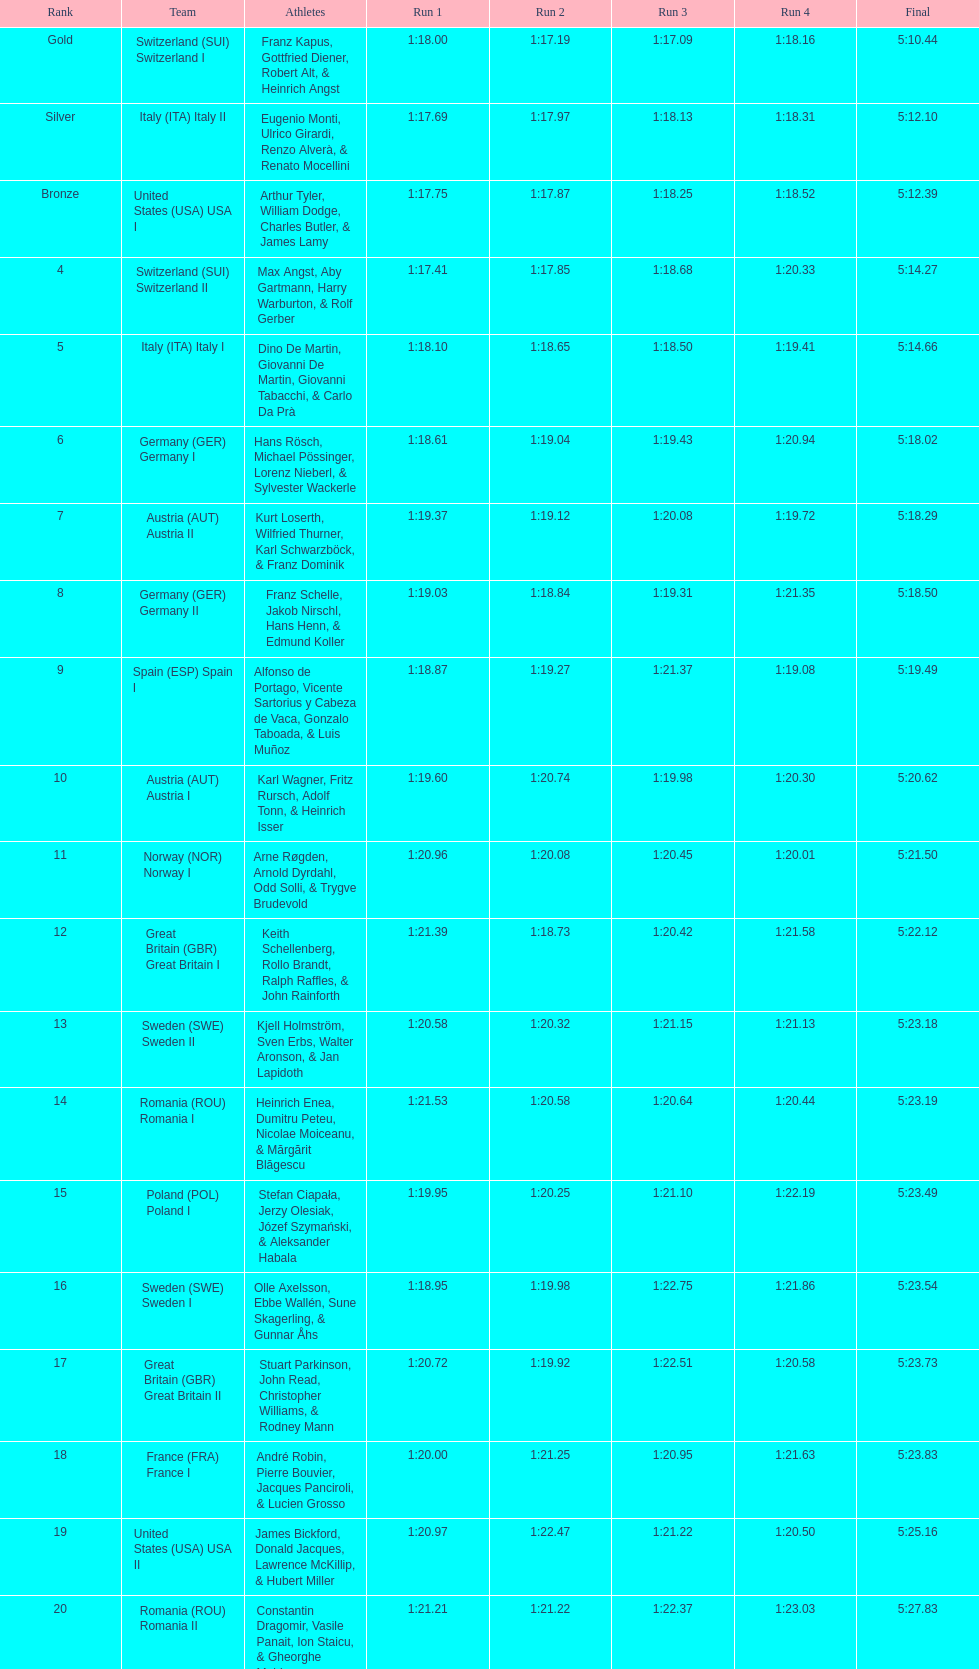Help me parse the entirety of this table. {'header': ['Rank', 'Team', 'Athletes', 'Run 1', 'Run 2', 'Run 3', 'Run 4', 'Final'], 'rows': [['Gold', 'Switzerland\xa0(SUI) Switzerland I', 'Franz Kapus, Gottfried Diener, Robert Alt, & Heinrich Angst', '1:18.00', '1:17.19', '1:17.09', '1:18.16', '5:10.44'], ['Silver', 'Italy\xa0(ITA) Italy II', 'Eugenio Monti, Ulrico Girardi, Renzo Alverà, & Renato Mocellini', '1:17.69', '1:17.97', '1:18.13', '1:18.31', '5:12.10'], ['Bronze', 'United States\xa0(USA) USA I', 'Arthur Tyler, William Dodge, Charles Butler, & James Lamy', '1:17.75', '1:17.87', '1:18.25', '1:18.52', '5:12.39'], ['4', 'Switzerland\xa0(SUI) Switzerland II', 'Max Angst, Aby Gartmann, Harry Warburton, & Rolf Gerber', '1:17.41', '1:17.85', '1:18.68', '1:20.33', '5:14.27'], ['5', 'Italy\xa0(ITA) Italy I', 'Dino De Martin, Giovanni De Martin, Giovanni Tabacchi, & Carlo Da Prà', '1:18.10', '1:18.65', '1:18.50', '1:19.41', '5:14.66'], ['6', 'Germany\xa0(GER) Germany I', 'Hans Rösch, Michael Pössinger, Lorenz Nieberl, & Sylvester Wackerle', '1:18.61', '1:19.04', '1:19.43', '1:20.94', '5:18.02'], ['7', 'Austria\xa0(AUT) Austria II', 'Kurt Loserth, Wilfried Thurner, Karl Schwarzböck, & Franz Dominik', '1:19.37', '1:19.12', '1:20.08', '1:19.72', '5:18.29'], ['8', 'Germany\xa0(GER) Germany II', 'Franz Schelle, Jakob Nirschl, Hans Henn, & Edmund Koller', '1:19.03', '1:18.84', '1:19.31', '1:21.35', '5:18.50'], ['9', 'Spain\xa0(ESP) Spain I', 'Alfonso de Portago, Vicente Sartorius y Cabeza de Vaca, Gonzalo Taboada, & Luis Muñoz', '1:18.87', '1:19.27', '1:21.37', '1:19.08', '5:19.49'], ['10', 'Austria\xa0(AUT) Austria I', 'Karl Wagner, Fritz Rursch, Adolf Tonn, & Heinrich Isser', '1:19.60', '1:20.74', '1:19.98', '1:20.30', '5:20.62'], ['11', 'Norway\xa0(NOR) Norway I', 'Arne Røgden, Arnold Dyrdahl, Odd Solli, & Trygve Brudevold', '1:20.96', '1:20.08', '1:20.45', '1:20.01', '5:21.50'], ['12', 'Great Britain\xa0(GBR) Great Britain I', 'Keith Schellenberg, Rollo Brandt, Ralph Raffles, & John Rainforth', '1:21.39', '1:18.73', '1:20.42', '1:21.58', '5:22.12'], ['13', 'Sweden\xa0(SWE) Sweden II', 'Kjell Holmström, Sven Erbs, Walter Aronson, & Jan Lapidoth', '1:20.58', '1:20.32', '1:21.15', '1:21.13', '5:23.18'], ['14', 'Romania\xa0(ROU) Romania I', 'Heinrich Enea, Dumitru Peteu, Nicolae Moiceanu, & Mărgărit Blăgescu', '1:21.53', '1:20.58', '1:20.64', '1:20.44', '5:23.19'], ['15', 'Poland\xa0(POL) Poland I', 'Stefan Ciapała, Jerzy Olesiak, Józef Szymański, & Aleksander Habala', '1:19.95', '1:20.25', '1:21.10', '1:22.19', '5:23.49'], ['16', 'Sweden\xa0(SWE) Sweden I', 'Olle Axelsson, Ebbe Wallén, Sune Skagerling, & Gunnar Åhs', '1:18.95', '1:19.98', '1:22.75', '1:21.86', '5:23.54'], ['17', 'Great Britain\xa0(GBR) Great Britain II', 'Stuart Parkinson, John Read, Christopher Williams, & Rodney Mann', '1:20.72', '1:19.92', '1:22.51', '1:20.58', '5:23.73'], ['18', 'France\xa0(FRA) France I', 'André Robin, Pierre Bouvier, Jacques Panciroli, & Lucien Grosso', '1:20.00', '1:21.25', '1:20.95', '1:21.63', '5:23.83'], ['19', 'United States\xa0(USA) USA II', 'James Bickford, Donald Jacques, Lawrence McKillip, & Hubert Miller', '1:20.97', '1:22.47', '1:21.22', '1:20.50', '5:25.16'], ['20', 'Romania\xa0(ROU) Romania II', 'Constantin Dragomir, Vasile Panait, Ion Staicu, & Gheorghe Moldoveanu', '1:21.21', '1:21.22', '1:22.37', '1:23.03', '5:27.83'], ['21', 'Poland\xa0(POL) Poland II', 'Aleksy Konieczny, Zygmunt Konieczny, Włodzimierz Źróbik, & Zbigniew Skowroński/Jan Dąbrowski(*)', '', '', '', '', '5:28.40']]} Which group ranked just above last place? Romania. 